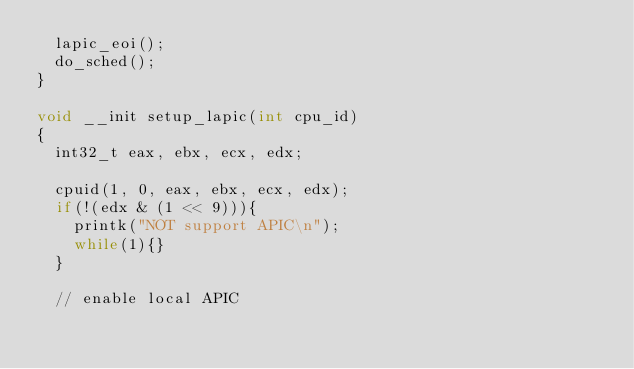<code> <loc_0><loc_0><loc_500><loc_500><_C_>	lapic_eoi();
	do_sched();
}

void __init setup_lapic(int cpu_id)
{
	int32_t eax, ebx, ecx, edx;

	cpuid(1, 0, eax, ebx, ecx, edx);
	if(!(edx & (1 << 9))){
		printk("NOT support APIC\n");
		while(1){}
	}

	// enable local APIC</code> 